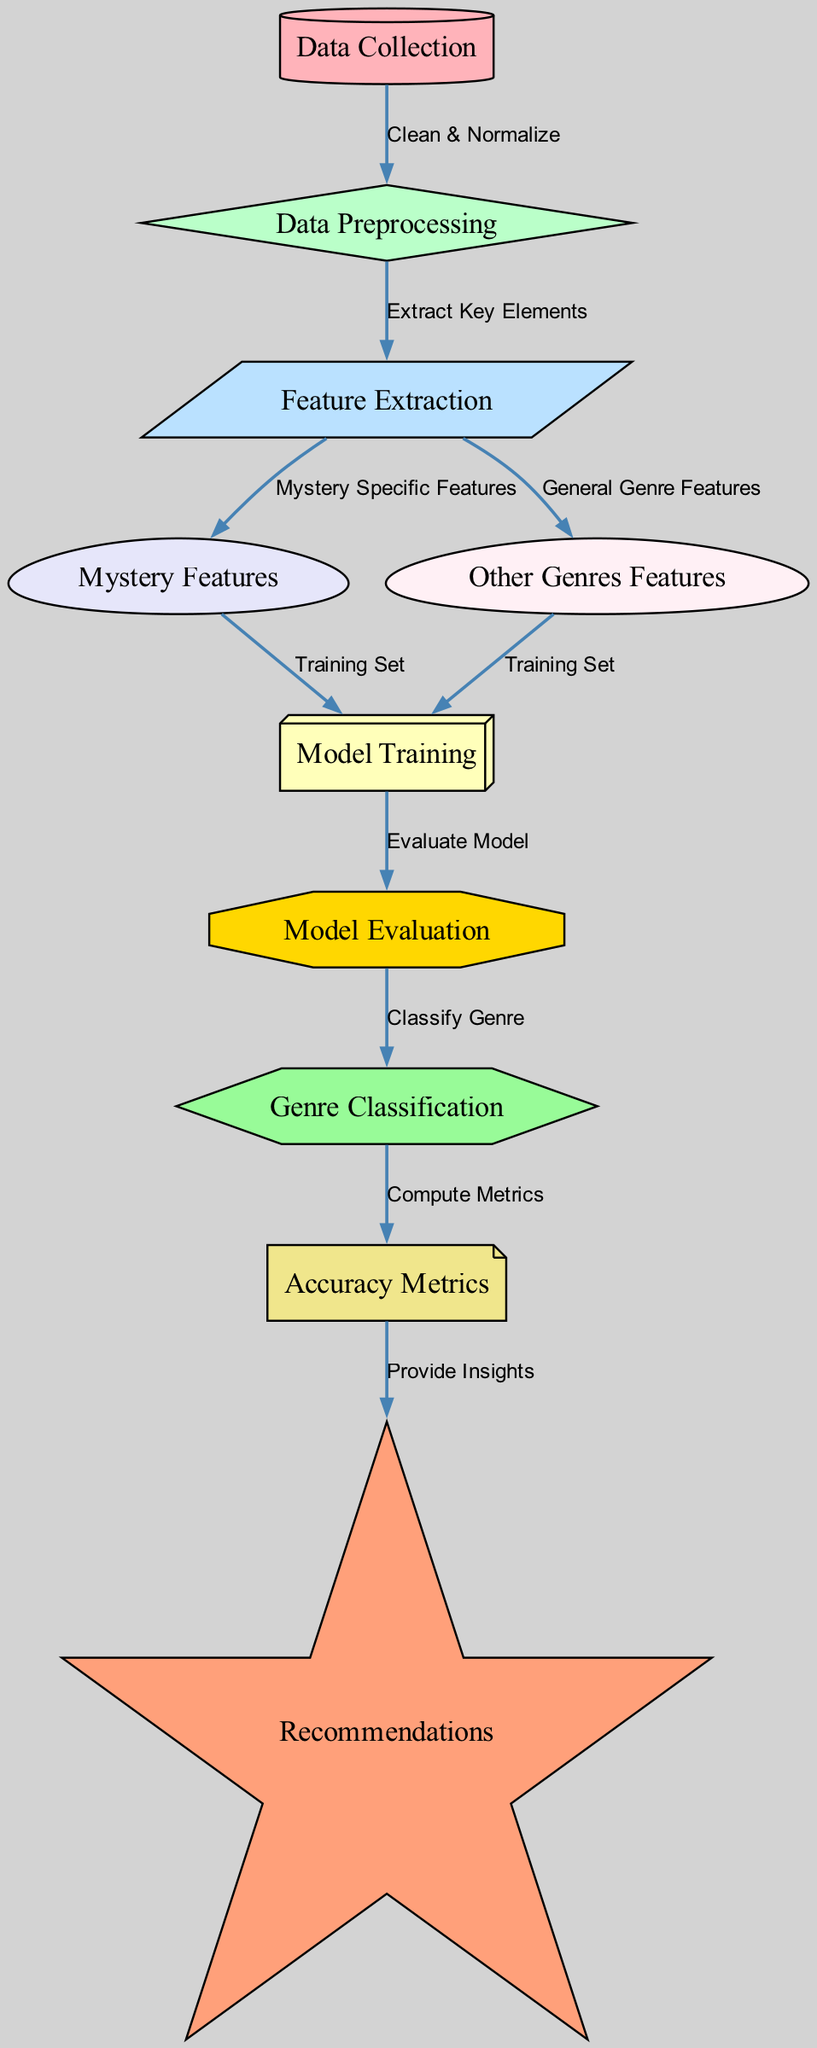What is the first step in the machine learning process? The first node in the diagram is labeled "Data Collection," indicating that gathering data is the initial step in the machine learning process.
Answer: Data Collection How many features are analyzed specifically for the mystery genre? In the diagram, there is a node specifically labeled "Mystery Features," which indicates that this step focuses on analyzing features that are particular to the mystery genre.
Answer: One What shape is the "Model Evaluation" node? The "Model Evaluation" node is shaped like an octagon, which can be observed visually in the diagram.
Answer: Octagon Which process follows "Model Training"? The diagram shows an arrow from "Model Training" to "Model Evaluation," indicating that model training is directly followed by model evaluation in the flow of the machine learning process.
Answer: Model Evaluation What is the purpose of the "Recommendations" node? The "Recommendations" node serves the purpose of providing insights based on the computed accuracy metrics, as indicated by the flow from the accuracy metrics to recommendations in the diagram.
Answer: Provide Insights How do the "Mystery Features" and "Other Genres Features" contribute to the training process? Both "Mystery Features" and "Other Genres Features" are shown to lead to the "Model Training" node, indicating that features from both categories are combined to form the training set used in the machine learning model.
Answer: Training Set What is used to clean and normalize data? The "Data Collection" node connects to the "Data Preprocessing" node, which is labeled with the phrase "Clean & Normalize," indicating that this is the stage where data cleaning and normalization occur.
Answer: Clean & Normalize What is computed after genre classification? Following the "Genre Classification" node, the flow indicates that "Accuracy Metrics" will be computed next, meaning that metrics are evaluated to determine the performance of the classification.
Answer: Compute Metrics Which node is responsible for extracting key elements from the data? The "Feature Extraction" node is responsible for extracting key elements from the data, as indicated by the connection from "Data Preprocessing."
Answer: Feature Extraction 